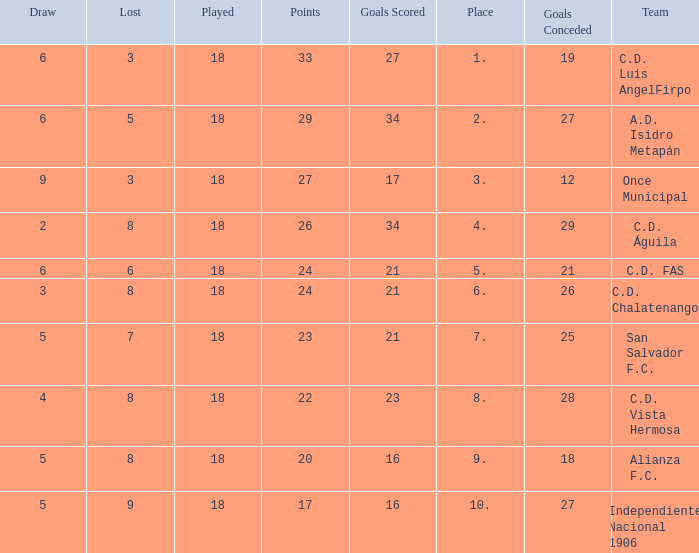What are the number of goals conceded that has a played greater than 18? 0.0. 